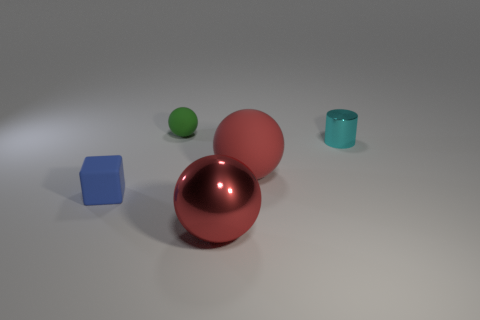Subtract all purple blocks. Subtract all red spheres. How many blocks are left? 1 Add 2 big red metal things. How many objects exist? 7 Subtract all blocks. How many objects are left? 4 Subtract all big things. Subtract all red matte objects. How many objects are left? 2 Add 5 rubber things. How many rubber things are left? 8 Add 3 blocks. How many blocks exist? 4 Subtract 0 cyan cubes. How many objects are left? 5 